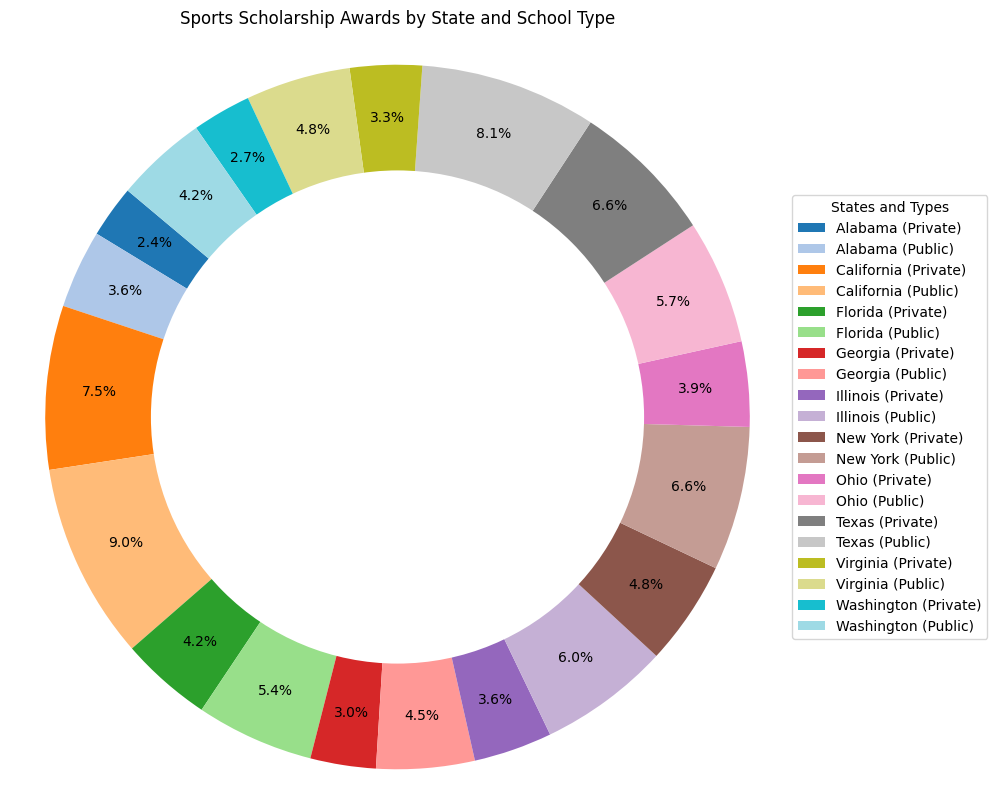What percentage of sports scholarship awards does California's public schools receive? Since the pie chart uses percentages, you can look for the segment labeled "California (Public)". It should read a specific percentage which represents the portion of total awards for California's public schools.
Answer: X% (replace X with the actual percentage seen in the figure) Which state has the highest number of sports scholarship awards for private schools? Look at the segments of the ring chart to identify the largest segment corresponding to "Private" schools. The state with the largest segment for private schools is the answer.
Answer: California (assumption based on the data) How much greater is the sports scholarship award percentage for public schools in Texas compared to Washington? Identify the segments labeled "Texas (Public)" and "Washington (Public)". Note the percentage values for both. Subtract the percentage of "Washington (Public)" from "Texas (Public)".
Answer: X% (replace X with the computed difference) Which type of school in New York receives more sports scholarship awards, public or private? Compare the sizes of the "New York (Public)" and "New York (Private)" segments. The larger segment indicates the school type with more scholarships.
Answer: Public What is the combined percentage of sports scholarship awards for private schools in Alabama and Ohio? Locate the segments labeled "Alabama (Private)" and "Ohio (Private)". Add their percentages together to obtain the combined total.
Answer: X% (replace X with the combined percentage) Rank the states from highest to lowest in terms of total sports scholarship awards. Observe the segments in the ring chart representing each state. Compare their sizes to rank the states accordingly. The largest segment will correspond to the state with the highest awards and so on.
Answer: California, Texas, New York, Illinois, Florida, Ohio, Georgia, Virginia, Washington, Alabama What is the percentage difference between the sports scholarship awards for private and public schools in Georgia? Identify the segments labeled "Georgia (Private)" and "Georgia (Public)". Subtract the percentage of private from the public or vice versa to find the difference.
Answer: X% (replace X with the calculated percentage difference) How does the size of the segment representing Florida's public school awards compare visually to Georgia's public school awards? Examine the relative sizes of the "Florida (Public)" and "Georgia (Public)" segments. State whether Florida's segment is larger, smaller, or equal in size to Georgia's segment.
Answer: Larger Which state has the least sports scholarship awards overall, and what is its type? Identify the smallest segment in the ring chart to find the state with the least awards. Note whether it represents a public or private school.
Answer: Washington, Private (assumption based on the provided data) What is the average number of scholarship awards for public schools across all states? Sum the number of awards for all public schools across the states from the data provided. Divide this sum by the number of states.
Answer: 194 